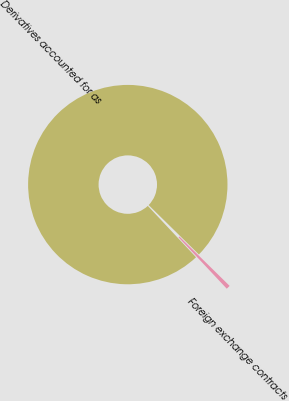Convert chart to OTSL. <chart><loc_0><loc_0><loc_500><loc_500><pie_chart><fcel>Derivatives accounted for as<fcel>Foreign exchange contracts<nl><fcel>99.36%<fcel>0.64%<nl></chart> 